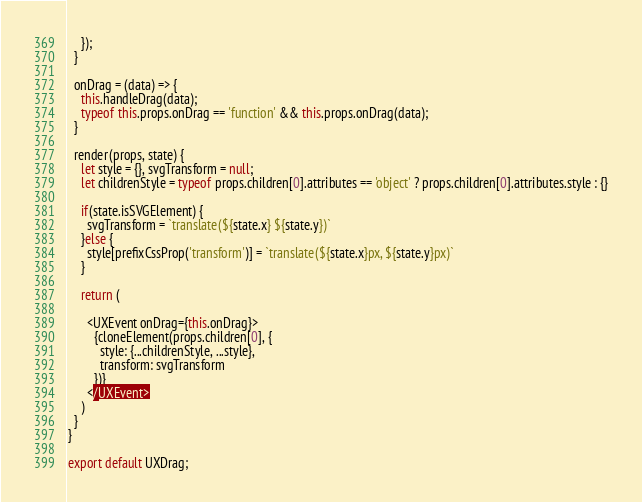<code> <loc_0><loc_0><loc_500><loc_500><_JavaScript_>    });
  }

  onDrag = (data) => {
    this.handleDrag(data);
    typeof this.props.onDrag == 'function' && this.props.onDrag(data);
  }

  render(props, state) {
    let style = {}, svgTransform = null;
    let childrenStyle = typeof props.children[0].attributes == 'object' ? props.children[0].attributes.style : {}

    if(state.isSVGElement) {
      svgTransform = `translate(${state.x} ${state.y})`
    }else {
      style[prefixCssProp('transform')] = `translate(${state.x}px, ${state.y}px)`
    }

    return (

      <UXEvent onDrag={this.onDrag}>
        {cloneElement(props.children[0], {
          style: {...childrenStyle, ...style},
          transform: svgTransform
        })}
      </UXEvent>
    )
  }
}

export default UXDrag;</code> 